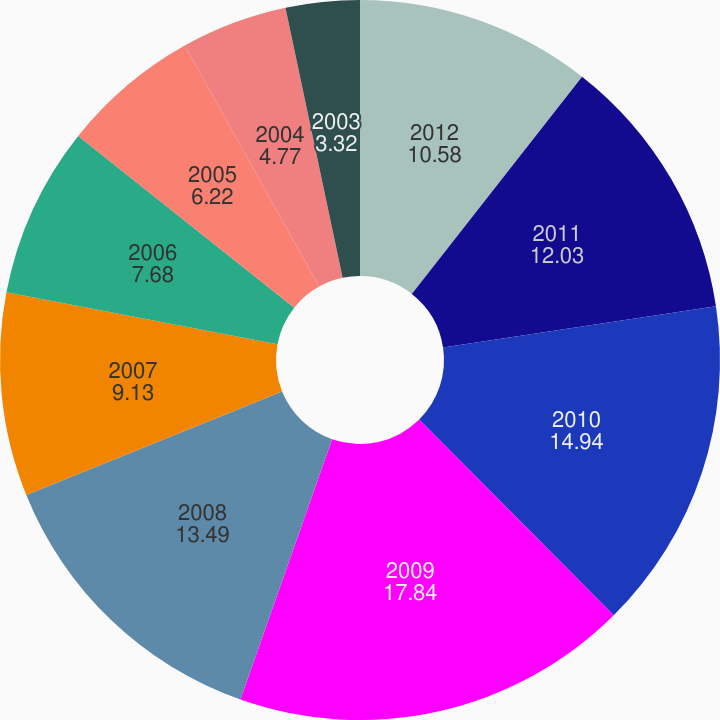Convert chart to OTSL. <chart><loc_0><loc_0><loc_500><loc_500><pie_chart><fcel>2012<fcel>2011<fcel>2010<fcel>2009<fcel>2008<fcel>2007<fcel>2006<fcel>2005<fcel>2004<fcel>2003<nl><fcel>10.58%<fcel>12.03%<fcel>14.94%<fcel>17.84%<fcel>13.49%<fcel>9.13%<fcel>7.68%<fcel>6.22%<fcel>4.77%<fcel>3.32%<nl></chart> 